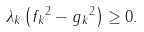<formula> <loc_0><loc_0><loc_500><loc_500>\lambda _ { k } \left ( \| f _ { k } \| ^ { 2 } - \| g _ { k } \| ^ { 2 } \right ) \geq 0 .</formula> 